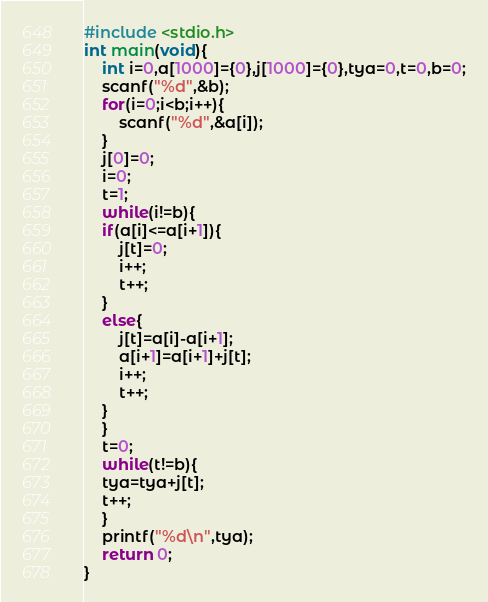<code> <loc_0><loc_0><loc_500><loc_500><_C_>#include <stdio.h>
int main(void){
	int i=0,a[1000]={0},j[1000]={0},tya=0,t=0,b=0;
	scanf("%d",&b);
	for(i=0;i<b;i++){
		scanf("%d",&a[i]);
	}
	j[0]=0;
	i=0;
	t=1;
	while(i!=b){
	if(a[i]<=a[i+1]){
		j[t]=0;
		i++;
		t++;
	}
	else{
		j[t]=a[i]-a[i+1];
		a[i+1]=a[i+1]+j[t];
		i++;
		t++;
	}
	}
	t=0;
	while(t!=b){
	tya=tya+j[t];
	t++;
	}
	printf("%d\n",tya);
	return 0;
}</code> 